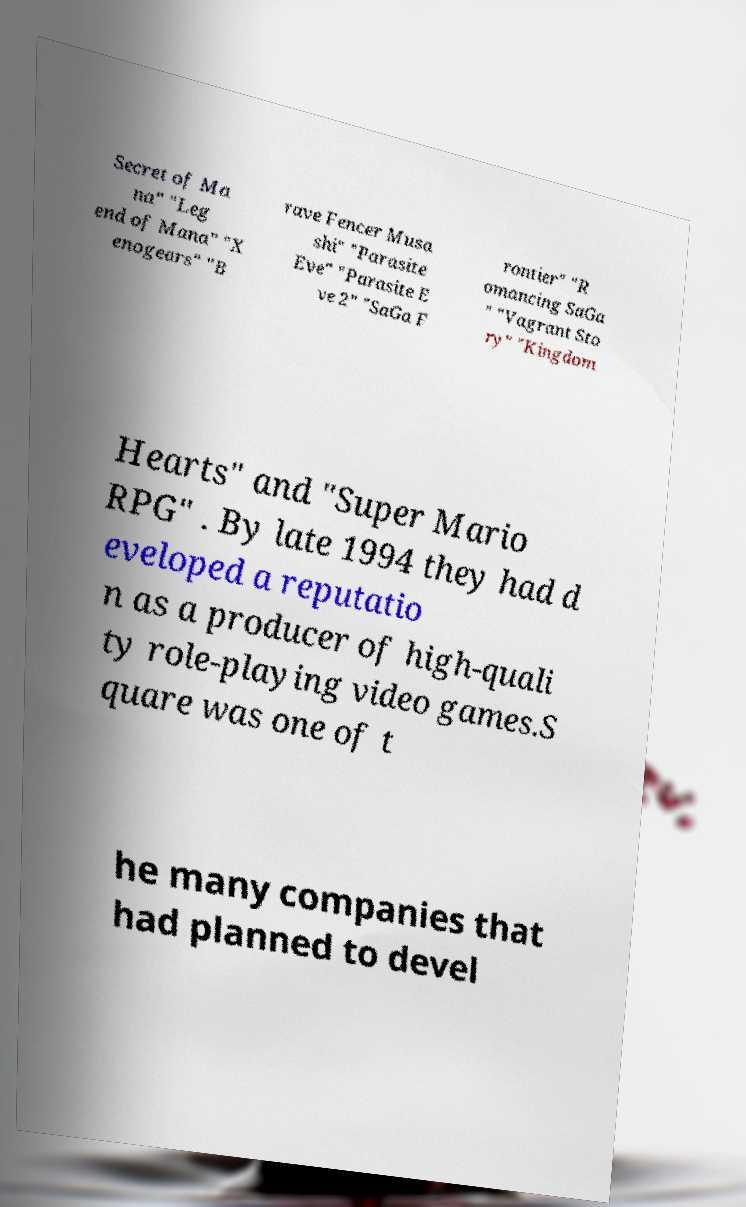Could you extract and type out the text from this image? Secret of Ma na" "Leg end of Mana" "X enogears" "B rave Fencer Musa shi" "Parasite Eve" "Parasite E ve 2" "SaGa F rontier" "R omancing SaGa " "Vagrant Sto ry" "Kingdom Hearts" and "Super Mario RPG" . By late 1994 they had d eveloped a reputatio n as a producer of high-quali ty role-playing video games.S quare was one of t he many companies that had planned to devel 